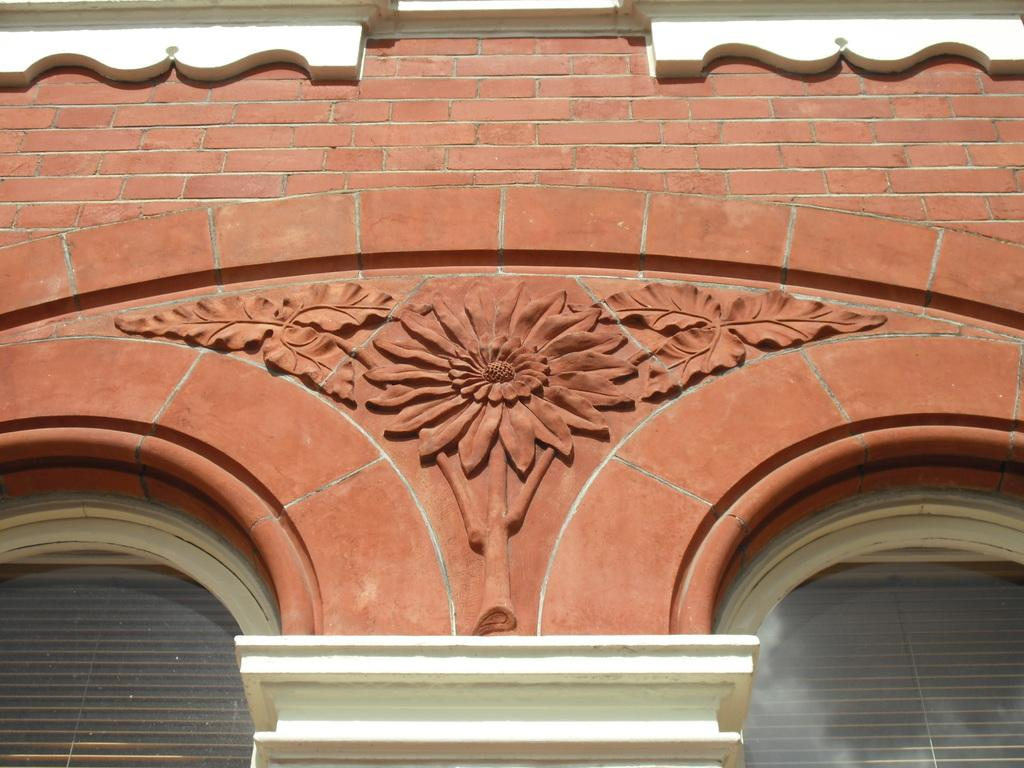What type of decoration is featured in the image? There is wall art in the image. What can be seen at the bottom of the image? Window shades are present at the bottom of the image. What type of material is visible at the top of the image? There is a brick wall at the top of the image. What type of clouds can be seen in the image? There are no clouds present in the image; it features wall art, window shades, and a brick wall. How does the rail contribute to the overall design of the image? There is no rail present in the image. 